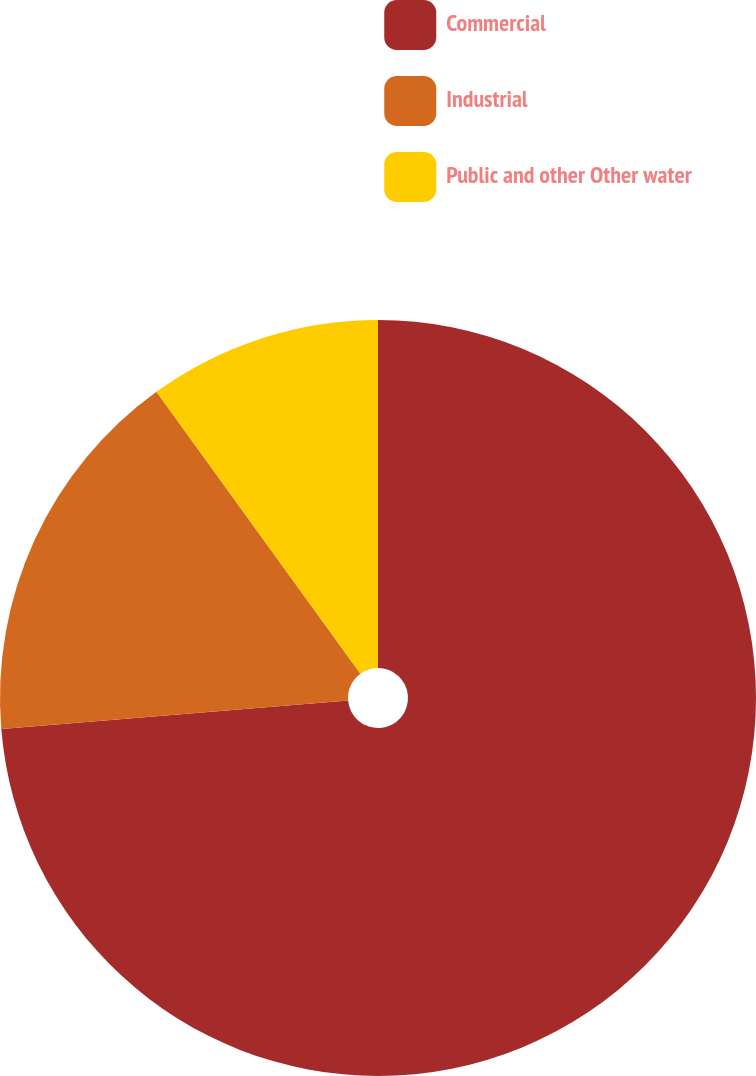Convert chart to OTSL. <chart><loc_0><loc_0><loc_500><loc_500><pie_chart><fcel>Commercial<fcel>Industrial<fcel>Public and other Other water<nl><fcel>73.69%<fcel>16.34%<fcel>9.97%<nl></chart> 